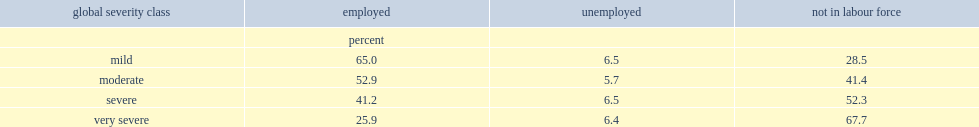What is the percentage of those with moderate disabilities stating that they are employed? 65.0. What is the percentage of those with severe disabilities stating that they are employed? 41.2. What is the percentage of those with very severe disabilities stating that they are employed? 25.9. What is the percentage of persons with mild disabilities reporting that they are not in the labour force? 28.5. What is the percentage of persons with very severe disabilities reporting that they are not in the labour force? 67.7. 